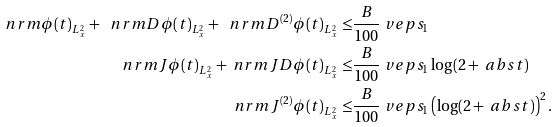Convert formula to latex. <formula><loc_0><loc_0><loc_500><loc_500>\ n r m { \phi ( t ) } _ { L ^ { 2 } _ { x } } + \ n r m { D \phi ( t ) } _ { L ^ { 2 } _ { x } } + \ n r m { D ^ { ( 2 ) } \phi ( t ) } _ { L ^ { 2 } _ { x } } \leq & \frac { B } { 1 0 0 } \ v e p s _ { 1 } \\ \ n r m { J \phi ( t ) } _ { L ^ { 2 } _ { x } } + \ n r m { J D \phi ( t ) } _ { L ^ { 2 } _ { x } } \leq & \frac { B } { 1 0 0 } \ v e p s _ { 1 } \log ( 2 + \ a b s { t } ) \\ \ n r m { J ^ { ( 2 ) } \phi ( t ) } _ { L ^ { 2 } _ { x } } \leq & \frac { B } { 1 0 0 } \ v e p s _ { 1 } \left ( \log ( 2 + \ a b s { t } ) \right ) ^ { 2 } .</formula> 